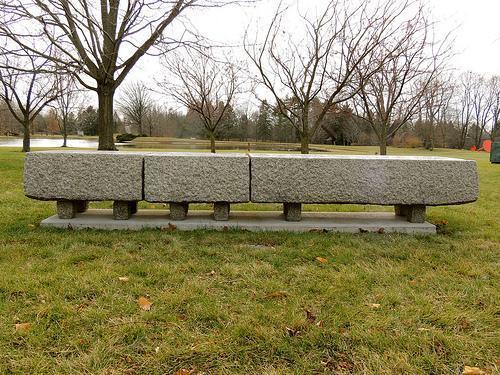How many cars are shown?
Give a very brief answer. 0. 